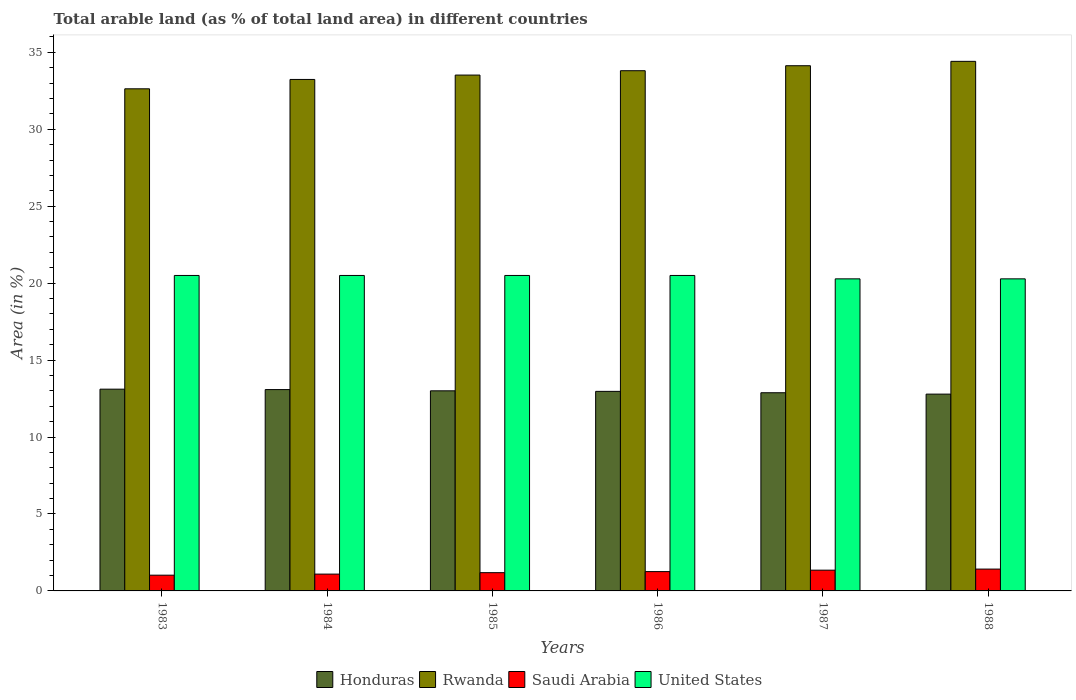How many different coloured bars are there?
Keep it short and to the point. 4. Are the number of bars per tick equal to the number of legend labels?
Offer a very short reply. Yes. How many bars are there on the 5th tick from the left?
Offer a terse response. 4. What is the percentage of arable land in United States in 1985?
Give a very brief answer. 20.5. Across all years, what is the maximum percentage of arable land in Saudi Arabia?
Offer a terse response. 1.42. Across all years, what is the minimum percentage of arable land in Rwanda?
Your answer should be very brief. 32.63. In which year was the percentage of arable land in Honduras maximum?
Your answer should be compact. 1983. In which year was the percentage of arable land in Saudi Arabia minimum?
Your response must be concise. 1983. What is the total percentage of arable land in Honduras in the graph?
Give a very brief answer. 77.84. What is the difference between the percentage of arable land in Rwanda in 1983 and that in 1986?
Provide a succinct answer. -1.18. What is the difference between the percentage of arable land in Saudi Arabia in 1986 and the percentage of arable land in United States in 1985?
Your answer should be compact. -19.24. What is the average percentage of arable land in Rwanda per year?
Make the answer very short. 33.62. In the year 1988, what is the difference between the percentage of arable land in Honduras and percentage of arable land in United States?
Give a very brief answer. -7.49. What is the ratio of the percentage of arable land in United States in 1983 to that in 1988?
Offer a very short reply. 1.01. Is the percentage of arable land in Rwanda in 1983 less than that in 1987?
Your answer should be compact. Yes. Is the difference between the percentage of arable land in Honduras in 1985 and 1988 greater than the difference between the percentage of arable land in United States in 1985 and 1988?
Provide a short and direct response. No. What is the difference between the highest and the second highest percentage of arable land in Honduras?
Offer a very short reply. 0.03. What is the difference between the highest and the lowest percentage of arable land in Saudi Arabia?
Provide a short and direct response. 0.4. In how many years, is the percentage of arable land in Rwanda greater than the average percentage of arable land in Rwanda taken over all years?
Provide a succinct answer. 3. What does the 2nd bar from the left in 1988 represents?
Ensure brevity in your answer.  Rwanda. What does the 1st bar from the right in 1988 represents?
Your response must be concise. United States. How many bars are there?
Ensure brevity in your answer.  24. Are the values on the major ticks of Y-axis written in scientific E-notation?
Provide a short and direct response. No. Where does the legend appear in the graph?
Give a very brief answer. Bottom center. How are the legend labels stacked?
Offer a very short reply. Horizontal. What is the title of the graph?
Your answer should be compact. Total arable land (as % of total land area) in different countries. What is the label or title of the Y-axis?
Keep it short and to the point. Area (in %). What is the Area (in %) of Honduras in 1983?
Your answer should be very brief. 13.11. What is the Area (in %) of Rwanda in 1983?
Your response must be concise. 32.63. What is the Area (in %) of Saudi Arabia in 1983?
Give a very brief answer. 1.02. What is the Area (in %) in United States in 1983?
Keep it short and to the point. 20.5. What is the Area (in %) in Honduras in 1984?
Offer a very short reply. 13.08. What is the Area (in %) in Rwanda in 1984?
Your answer should be compact. 33.24. What is the Area (in %) of Saudi Arabia in 1984?
Offer a terse response. 1.09. What is the Area (in %) in United States in 1984?
Offer a very short reply. 20.5. What is the Area (in %) of Honduras in 1985?
Keep it short and to the point. 13. What is the Area (in %) of Rwanda in 1985?
Your response must be concise. 33.52. What is the Area (in %) in Saudi Arabia in 1985?
Your answer should be compact. 1.19. What is the Area (in %) in United States in 1985?
Provide a succinct answer. 20.5. What is the Area (in %) in Honduras in 1986?
Provide a succinct answer. 12.97. What is the Area (in %) of Rwanda in 1986?
Give a very brief answer. 33.81. What is the Area (in %) of Saudi Arabia in 1986?
Offer a very short reply. 1.26. What is the Area (in %) in United States in 1986?
Make the answer very short. 20.5. What is the Area (in %) of Honduras in 1987?
Provide a short and direct response. 12.88. What is the Area (in %) of Rwanda in 1987?
Your answer should be very brief. 34.13. What is the Area (in %) in Saudi Arabia in 1987?
Your response must be concise. 1.35. What is the Area (in %) in United States in 1987?
Make the answer very short. 20.28. What is the Area (in %) of Honduras in 1988?
Your answer should be compact. 12.79. What is the Area (in %) of Rwanda in 1988?
Make the answer very short. 34.41. What is the Area (in %) of Saudi Arabia in 1988?
Ensure brevity in your answer.  1.42. What is the Area (in %) of United States in 1988?
Your response must be concise. 20.28. Across all years, what is the maximum Area (in %) in Honduras?
Ensure brevity in your answer.  13.11. Across all years, what is the maximum Area (in %) in Rwanda?
Ensure brevity in your answer.  34.41. Across all years, what is the maximum Area (in %) in Saudi Arabia?
Make the answer very short. 1.42. Across all years, what is the maximum Area (in %) in United States?
Your response must be concise. 20.5. Across all years, what is the minimum Area (in %) in Honduras?
Keep it short and to the point. 12.79. Across all years, what is the minimum Area (in %) of Rwanda?
Offer a terse response. 32.63. Across all years, what is the minimum Area (in %) of Saudi Arabia?
Offer a terse response. 1.02. Across all years, what is the minimum Area (in %) in United States?
Keep it short and to the point. 20.28. What is the total Area (in %) in Honduras in the graph?
Offer a very short reply. 77.84. What is the total Area (in %) in Rwanda in the graph?
Keep it short and to the point. 201.74. What is the total Area (in %) of Saudi Arabia in the graph?
Ensure brevity in your answer.  7.33. What is the total Area (in %) in United States in the graph?
Ensure brevity in your answer.  122.56. What is the difference between the Area (in %) in Honduras in 1983 and that in 1984?
Provide a short and direct response. 0.03. What is the difference between the Area (in %) of Rwanda in 1983 and that in 1984?
Make the answer very short. -0.61. What is the difference between the Area (in %) in Saudi Arabia in 1983 and that in 1984?
Provide a succinct answer. -0.07. What is the difference between the Area (in %) in Honduras in 1983 and that in 1985?
Offer a terse response. 0.11. What is the difference between the Area (in %) in Rwanda in 1983 and that in 1985?
Provide a succinct answer. -0.89. What is the difference between the Area (in %) of Saudi Arabia in 1983 and that in 1985?
Provide a short and direct response. -0.16. What is the difference between the Area (in %) in Honduras in 1983 and that in 1986?
Keep it short and to the point. 0.14. What is the difference between the Area (in %) of Rwanda in 1983 and that in 1986?
Keep it short and to the point. -1.18. What is the difference between the Area (in %) of Saudi Arabia in 1983 and that in 1986?
Your answer should be compact. -0.23. What is the difference between the Area (in %) of United States in 1983 and that in 1986?
Offer a terse response. 0. What is the difference between the Area (in %) of Honduras in 1983 and that in 1987?
Provide a short and direct response. 0.23. What is the difference between the Area (in %) of Rwanda in 1983 and that in 1987?
Give a very brief answer. -1.5. What is the difference between the Area (in %) of Saudi Arabia in 1983 and that in 1987?
Give a very brief answer. -0.33. What is the difference between the Area (in %) in United States in 1983 and that in 1987?
Your answer should be compact. 0.22. What is the difference between the Area (in %) of Honduras in 1983 and that in 1988?
Ensure brevity in your answer.  0.32. What is the difference between the Area (in %) of Rwanda in 1983 and that in 1988?
Ensure brevity in your answer.  -1.78. What is the difference between the Area (in %) of Saudi Arabia in 1983 and that in 1988?
Give a very brief answer. -0.4. What is the difference between the Area (in %) of United States in 1983 and that in 1988?
Give a very brief answer. 0.22. What is the difference between the Area (in %) in Honduras in 1984 and that in 1985?
Give a very brief answer. 0.08. What is the difference between the Area (in %) in Rwanda in 1984 and that in 1985?
Your answer should be very brief. -0.28. What is the difference between the Area (in %) of Saudi Arabia in 1984 and that in 1985?
Your response must be concise. -0.09. What is the difference between the Area (in %) in Honduras in 1984 and that in 1986?
Give a very brief answer. 0.12. What is the difference between the Area (in %) of Rwanda in 1984 and that in 1986?
Your response must be concise. -0.57. What is the difference between the Area (in %) of Saudi Arabia in 1984 and that in 1986?
Ensure brevity in your answer.  -0.16. What is the difference between the Area (in %) of Honduras in 1984 and that in 1987?
Offer a very short reply. 0.21. What is the difference between the Area (in %) of Rwanda in 1984 and that in 1987?
Keep it short and to the point. -0.89. What is the difference between the Area (in %) of Saudi Arabia in 1984 and that in 1987?
Give a very brief answer. -0.26. What is the difference between the Area (in %) in United States in 1984 and that in 1987?
Offer a terse response. 0.22. What is the difference between the Area (in %) in Honduras in 1984 and that in 1988?
Your response must be concise. 0.29. What is the difference between the Area (in %) in Rwanda in 1984 and that in 1988?
Provide a succinct answer. -1.18. What is the difference between the Area (in %) in Saudi Arabia in 1984 and that in 1988?
Make the answer very short. -0.33. What is the difference between the Area (in %) in United States in 1984 and that in 1988?
Give a very brief answer. 0.22. What is the difference between the Area (in %) in Honduras in 1985 and that in 1986?
Make the answer very short. 0.04. What is the difference between the Area (in %) of Rwanda in 1985 and that in 1986?
Provide a short and direct response. -0.28. What is the difference between the Area (in %) in Saudi Arabia in 1985 and that in 1986?
Keep it short and to the point. -0.07. What is the difference between the Area (in %) of Honduras in 1985 and that in 1987?
Keep it short and to the point. 0.13. What is the difference between the Area (in %) in Rwanda in 1985 and that in 1987?
Your answer should be very brief. -0.61. What is the difference between the Area (in %) of Saudi Arabia in 1985 and that in 1987?
Give a very brief answer. -0.16. What is the difference between the Area (in %) of United States in 1985 and that in 1987?
Give a very brief answer. 0.22. What is the difference between the Area (in %) in Honduras in 1985 and that in 1988?
Keep it short and to the point. 0.21. What is the difference between the Area (in %) of Rwanda in 1985 and that in 1988?
Offer a terse response. -0.89. What is the difference between the Area (in %) in Saudi Arabia in 1985 and that in 1988?
Your answer should be compact. -0.23. What is the difference between the Area (in %) in United States in 1985 and that in 1988?
Your answer should be very brief. 0.22. What is the difference between the Area (in %) of Honduras in 1986 and that in 1987?
Your answer should be very brief. 0.09. What is the difference between the Area (in %) in Rwanda in 1986 and that in 1987?
Keep it short and to the point. -0.32. What is the difference between the Area (in %) of Saudi Arabia in 1986 and that in 1987?
Offer a terse response. -0.09. What is the difference between the Area (in %) in United States in 1986 and that in 1987?
Keep it short and to the point. 0.22. What is the difference between the Area (in %) in Honduras in 1986 and that in 1988?
Keep it short and to the point. 0.18. What is the difference between the Area (in %) in Rwanda in 1986 and that in 1988?
Your answer should be very brief. -0.61. What is the difference between the Area (in %) in Saudi Arabia in 1986 and that in 1988?
Keep it short and to the point. -0.16. What is the difference between the Area (in %) in United States in 1986 and that in 1988?
Ensure brevity in your answer.  0.22. What is the difference between the Area (in %) of Honduras in 1987 and that in 1988?
Your answer should be very brief. 0.09. What is the difference between the Area (in %) in Rwanda in 1987 and that in 1988?
Offer a very short reply. -0.28. What is the difference between the Area (in %) in Saudi Arabia in 1987 and that in 1988?
Your answer should be very brief. -0.07. What is the difference between the Area (in %) in United States in 1987 and that in 1988?
Offer a very short reply. 0. What is the difference between the Area (in %) in Honduras in 1983 and the Area (in %) in Rwanda in 1984?
Your answer should be very brief. -20.13. What is the difference between the Area (in %) in Honduras in 1983 and the Area (in %) in Saudi Arabia in 1984?
Provide a succinct answer. 12.02. What is the difference between the Area (in %) of Honduras in 1983 and the Area (in %) of United States in 1984?
Ensure brevity in your answer.  -7.39. What is the difference between the Area (in %) of Rwanda in 1983 and the Area (in %) of Saudi Arabia in 1984?
Ensure brevity in your answer.  31.54. What is the difference between the Area (in %) of Rwanda in 1983 and the Area (in %) of United States in 1984?
Give a very brief answer. 12.13. What is the difference between the Area (in %) of Saudi Arabia in 1983 and the Area (in %) of United States in 1984?
Offer a terse response. -19.48. What is the difference between the Area (in %) in Honduras in 1983 and the Area (in %) in Rwanda in 1985?
Your answer should be compact. -20.41. What is the difference between the Area (in %) in Honduras in 1983 and the Area (in %) in Saudi Arabia in 1985?
Your response must be concise. 11.92. What is the difference between the Area (in %) of Honduras in 1983 and the Area (in %) of United States in 1985?
Provide a short and direct response. -7.39. What is the difference between the Area (in %) in Rwanda in 1983 and the Area (in %) in Saudi Arabia in 1985?
Make the answer very short. 31.44. What is the difference between the Area (in %) of Rwanda in 1983 and the Area (in %) of United States in 1985?
Offer a very short reply. 12.13. What is the difference between the Area (in %) in Saudi Arabia in 1983 and the Area (in %) in United States in 1985?
Your response must be concise. -19.48. What is the difference between the Area (in %) of Honduras in 1983 and the Area (in %) of Rwanda in 1986?
Offer a very short reply. -20.7. What is the difference between the Area (in %) of Honduras in 1983 and the Area (in %) of Saudi Arabia in 1986?
Provide a succinct answer. 11.86. What is the difference between the Area (in %) of Honduras in 1983 and the Area (in %) of United States in 1986?
Your answer should be very brief. -7.39. What is the difference between the Area (in %) in Rwanda in 1983 and the Area (in %) in Saudi Arabia in 1986?
Provide a short and direct response. 31.37. What is the difference between the Area (in %) of Rwanda in 1983 and the Area (in %) of United States in 1986?
Make the answer very short. 12.13. What is the difference between the Area (in %) of Saudi Arabia in 1983 and the Area (in %) of United States in 1986?
Your answer should be compact. -19.48. What is the difference between the Area (in %) of Honduras in 1983 and the Area (in %) of Rwanda in 1987?
Provide a short and direct response. -21.02. What is the difference between the Area (in %) of Honduras in 1983 and the Area (in %) of Saudi Arabia in 1987?
Give a very brief answer. 11.76. What is the difference between the Area (in %) of Honduras in 1983 and the Area (in %) of United States in 1987?
Offer a very short reply. -7.17. What is the difference between the Area (in %) of Rwanda in 1983 and the Area (in %) of Saudi Arabia in 1987?
Provide a succinct answer. 31.28. What is the difference between the Area (in %) in Rwanda in 1983 and the Area (in %) in United States in 1987?
Your answer should be compact. 12.35. What is the difference between the Area (in %) in Saudi Arabia in 1983 and the Area (in %) in United States in 1987?
Offer a terse response. -19.26. What is the difference between the Area (in %) of Honduras in 1983 and the Area (in %) of Rwanda in 1988?
Your answer should be very brief. -21.3. What is the difference between the Area (in %) of Honduras in 1983 and the Area (in %) of Saudi Arabia in 1988?
Your answer should be compact. 11.69. What is the difference between the Area (in %) of Honduras in 1983 and the Area (in %) of United States in 1988?
Your response must be concise. -7.17. What is the difference between the Area (in %) of Rwanda in 1983 and the Area (in %) of Saudi Arabia in 1988?
Your answer should be very brief. 31.21. What is the difference between the Area (in %) in Rwanda in 1983 and the Area (in %) in United States in 1988?
Your response must be concise. 12.35. What is the difference between the Area (in %) in Saudi Arabia in 1983 and the Area (in %) in United States in 1988?
Give a very brief answer. -19.26. What is the difference between the Area (in %) of Honduras in 1984 and the Area (in %) of Rwanda in 1985?
Offer a terse response. -20.44. What is the difference between the Area (in %) of Honduras in 1984 and the Area (in %) of Saudi Arabia in 1985?
Offer a terse response. 11.9. What is the difference between the Area (in %) in Honduras in 1984 and the Area (in %) in United States in 1985?
Your response must be concise. -7.42. What is the difference between the Area (in %) of Rwanda in 1984 and the Area (in %) of Saudi Arabia in 1985?
Make the answer very short. 32.05. What is the difference between the Area (in %) of Rwanda in 1984 and the Area (in %) of United States in 1985?
Offer a very short reply. 12.74. What is the difference between the Area (in %) in Saudi Arabia in 1984 and the Area (in %) in United States in 1985?
Ensure brevity in your answer.  -19.41. What is the difference between the Area (in %) of Honduras in 1984 and the Area (in %) of Rwanda in 1986?
Your answer should be compact. -20.72. What is the difference between the Area (in %) in Honduras in 1984 and the Area (in %) in Saudi Arabia in 1986?
Provide a short and direct response. 11.83. What is the difference between the Area (in %) in Honduras in 1984 and the Area (in %) in United States in 1986?
Make the answer very short. -7.42. What is the difference between the Area (in %) in Rwanda in 1984 and the Area (in %) in Saudi Arabia in 1986?
Give a very brief answer. 31.98. What is the difference between the Area (in %) of Rwanda in 1984 and the Area (in %) of United States in 1986?
Give a very brief answer. 12.74. What is the difference between the Area (in %) of Saudi Arabia in 1984 and the Area (in %) of United States in 1986?
Give a very brief answer. -19.41. What is the difference between the Area (in %) of Honduras in 1984 and the Area (in %) of Rwanda in 1987?
Provide a succinct answer. -21.05. What is the difference between the Area (in %) in Honduras in 1984 and the Area (in %) in Saudi Arabia in 1987?
Your answer should be compact. 11.74. What is the difference between the Area (in %) in Honduras in 1984 and the Area (in %) in United States in 1987?
Give a very brief answer. -7.2. What is the difference between the Area (in %) of Rwanda in 1984 and the Area (in %) of Saudi Arabia in 1987?
Provide a succinct answer. 31.89. What is the difference between the Area (in %) of Rwanda in 1984 and the Area (in %) of United States in 1987?
Provide a succinct answer. 12.96. What is the difference between the Area (in %) of Saudi Arabia in 1984 and the Area (in %) of United States in 1987?
Offer a terse response. -19.19. What is the difference between the Area (in %) in Honduras in 1984 and the Area (in %) in Rwanda in 1988?
Keep it short and to the point. -21.33. What is the difference between the Area (in %) of Honduras in 1984 and the Area (in %) of Saudi Arabia in 1988?
Your response must be concise. 11.67. What is the difference between the Area (in %) in Honduras in 1984 and the Area (in %) in United States in 1988?
Give a very brief answer. -7.2. What is the difference between the Area (in %) of Rwanda in 1984 and the Area (in %) of Saudi Arabia in 1988?
Offer a terse response. 31.82. What is the difference between the Area (in %) in Rwanda in 1984 and the Area (in %) in United States in 1988?
Ensure brevity in your answer.  12.96. What is the difference between the Area (in %) in Saudi Arabia in 1984 and the Area (in %) in United States in 1988?
Offer a terse response. -19.19. What is the difference between the Area (in %) in Honduras in 1985 and the Area (in %) in Rwanda in 1986?
Offer a very short reply. -20.8. What is the difference between the Area (in %) of Honduras in 1985 and the Area (in %) of Saudi Arabia in 1986?
Provide a short and direct response. 11.75. What is the difference between the Area (in %) in Honduras in 1985 and the Area (in %) in United States in 1986?
Your answer should be compact. -7.5. What is the difference between the Area (in %) of Rwanda in 1985 and the Area (in %) of Saudi Arabia in 1986?
Keep it short and to the point. 32.27. What is the difference between the Area (in %) in Rwanda in 1985 and the Area (in %) in United States in 1986?
Offer a very short reply. 13.02. What is the difference between the Area (in %) of Saudi Arabia in 1985 and the Area (in %) of United States in 1986?
Your answer should be compact. -19.31. What is the difference between the Area (in %) in Honduras in 1985 and the Area (in %) in Rwanda in 1987?
Your response must be concise. -21.13. What is the difference between the Area (in %) of Honduras in 1985 and the Area (in %) of Saudi Arabia in 1987?
Your answer should be compact. 11.65. What is the difference between the Area (in %) in Honduras in 1985 and the Area (in %) in United States in 1987?
Offer a very short reply. -7.28. What is the difference between the Area (in %) in Rwanda in 1985 and the Area (in %) in Saudi Arabia in 1987?
Give a very brief answer. 32.17. What is the difference between the Area (in %) of Rwanda in 1985 and the Area (in %) of United States in 1987?
Your answer should be compact. 13.24. What is the difference between the Area (in %) in Saudi Arabia in 1985 and the Area (in %) in United States in 1987?
Your answer should be compact. -19.09. What is the difference between the Area (in %) in Honduras in 1985 and the Area (in %) in Rwanda in 1988?
Offer a terse response. -21.41. What is the difference between the Area (in %) in Honduras in 1985 and the Area (in %) in Saudi Arabia in 1988?
Ensure brevity in your answer.  11.59. What is the difference between the Area (in %) of Honduras in 1985 and the Area (in %) of United States in 1988?
Your answer should be compact. -7.28. What is the difference between the Area (in %) in Rwanda in 1985 and the Area (in %) in Saudi Arabia in 1988?
Make the answer very short. 32.1. What is the difference between the Area (in %) in Rwanda in 1985 and the Area (in %) in United States in 1988?
Offer a terse response. 13.24. What is the difference between the Area (in %) in Saudi Arabia in 1985 and the Area (in %) in United States in 1988?
Give a very brief answer. -19.09. What is the difference between the Area (in %) of Honduras in 1986 and the Area (in %) of Rwanda in 1987?
Your answer should be compact. -21.16. What is the difference between the Area (in %) of Honduras in 1986 and the Area (in %) of Saudi Arabia in 1987?
Provide a short and direct response. 11.62. What is the difference between the Area (in %) in Honduras in 1986 and the Area (in %) in United States in 1987?
Keep it short and to the point. -7.31. What is the difference between the Area (in %) in Rwanda in 1986 and the Area (in %) in Saudi Arabia in 1987?
Offer a very short reply. 32.46. What is the difference between the Area (in %) in Rwanda in 1986 and the Area (in %) in United States in 1987?
Ensure brevity in your answer.  13.53. What is the difference between the Area (in %) of Saudi Arabia in 1986 and the Area (in %) of United States in 1987?
Offer a very short reply. -19.02. What is the difference between the Area (in %) of Honduras in 1986 and the Area (in %) of Rwanda in 1988?
Offer a terse response. -21.45. What is the difference between the Area (in %) in Honduras in 1986 and the Area (in %) in Saudi Arabia in 1988?
Provide a short and direct response. 11.55. What is the difference between the Area (in %) of Honduras in 1986 and the Area (in %) of United States in 1988?
Keep it short and to the point. -7.31. What is the difference between the Area (in %) in Rwanda in 1986 and the Area (in %) in Saudi Arabia in 1988?
Provide a short and direct response. 32.39. What is the difference between the Area (in %) in Rwanda in 1986 and the Area (in %) in United States in 1988?
Offer a terse response. 13.53. What is the difference between the Area (in %) in Saudi Arabia in 1986 and the Area (in %) in United States in 1988?
Keep it short and to the point. -19.02. What is the difference between the Area (in %) in Honduras in 1987 and the Area (in %) in Rwanda in 1988?
Provide a succinct answer. -21.54. What is the difference between the Area (in %) in Honduras in 1987 and the Area (in %) in Saudi Arabia in 1988?
Offer a terse response. 11.46. What is the difference between the Area (in %) of Honduras in 1987 and the Area (in %) of United States in 1988?
Give a very brief answer. -7.4. What is the difference between the Area (in %) of Rwanda in 1987 and the Area (in %) of Saudi Arabia in 1988?
Make the answer very short. 32.71. What is the difference between the Area (in %) of Rwanda in 1987 and the Area (in %) of United States in 1988?
Give a very brief answer. 13.85. What is the difference between the Area (in %) in Saudi Arabia in 1987 and the Area (in %) in United States in 1988?
Offer a very short reply. -18.93. What is the average Area (in %) in Honduras per year?
Your answer should be compact. 12.97. What is the average Area (in %) of Rwanda per year?
Your response must be concise. 33.62. What is the average Area (in %) in Saudi Arabia per year?
Your answer should be compact. 1.22. What is the average Area (in %) in United States per year?
Your answer should be very brief. 20.43. In the year 1983, what is the difference between the Area (in %) of Honduras and Area (in %) of Rwanda?
Provide a short and direct response. -19.52. In the year 1983, what is the difference between the Area (in %) of Honduras and Area (in %) of Saudi Arabia?
Provide a short and direct response. 12.09. In the year 1983, what is the difference between the Area (in %) in Honduras and Area (in %) in United States?
Provide a short and direct response. -7.39. In the year 1983, what is the difference between the Area (in %) in Rwanda and Area (in %) in Saudi Arabia?
Ensure brevity in your answer.  31.61. In the year 1983, what is the difference between the Area (in %) of Rwanda and Area (in %) of United States?
Your answer should be compact. 12.13. In the year 1983, what is the difference between the Area (in %) of Saudi Arabia and Area (in %) of United States?
Keep it short and to the point. -19.48. In the year 1984, what is the difference between the Area (in %) of Honduras and Area (in %) of Rwanda?
Provide a short and direct response. -20.15. In the year 1984, what is the difference between the Area (in %) in Honduras and Area (in %) in Saudi Arabia?
Your answer should be very brief. 11.99. In the year 1984, what is the difference between the Area (in %) of Honduras and Area (in %) of United States?
Your response must be concise. -7.42. In the year 1984, what is the difference between the Area (in %) of Rwanda and Area (in %) of Saudi Arabia?
Your answer should be compact. 32.15. In the year 1984, what is the difference between the Area (in %) in Rwanda and Area (in %) in United States?
Your answer should be very brief. 12.74. In the year 1984, what is the difference between the Area (in %) in Saudi Arabia and Area (in %) in United States?
Your response must be concise. -19.41. In the year 1985, what is the difference between the Area (in %) of Honduras and Area (in %) of Rwanda?
Offer a terse response. -20.52. In the year 1985, what is the difference between the Area (in %) in Honduras and Area (in %) in Saudi Arabia?
Your response must be concise. 11.82. In the year 1985, what is the difference between the Area (in %) of Honduras and Area (in %) of United States?
Provide a short and direct response. -7.5. In the year 1985, what is the difference between the Area (in %) of Rwanda and Area (in %) of Saudi Arabia?
Provide a short and direct response. 32.34. In the year 1985, what is the difference between the Area (in %) in Rwanda and Area (in %) in United States?
Keep it short and to the point. 13.02. In the year 1985, what is the difference between the Area (in %) in Saudi Arabia and Area (in %) in United States?
Keep it short and to the point. -19.31. In the year 1986, what is the difference between the Area (in %) of Honduras and Area (in %) of Rwanda?
Give a very brief answer. -20.84. In the year 1986, what is the difference between the Area (in %) of Honduras and Area (in %) of Saudi Arabia?
Your answer should be compact. 11.71. In the year 1986, what is the difference between the Area (in %) of Honduras and Area (in %) of United States?
Offer a terse response. -7.53. In the year 1986, what is the difference between the Area (in %) in Rwanda and Area (in %) in Saudi Arabia?
Offer a very short reply. 32.55. In the year 1986, what is the difference between the Area (in %) in Rwanda and Area (in %) in United States?
Your answer should be very brief. 13.31. In the year 1986, what is the difference between the Area (in %) in Saudi Arabia and Area (in %) in United States?
Provide a succinct answer. -19.24. In the year 1987, what is the difference between the Area (in %) of Honduras and Area (in %) of Rwanda?
Offer a terse response. -21.25. In the year 1987, what is the difference between the Area (in %) in Honduras and Area (in %) in Saudi Arabia?
Your answer should be compact. 11.53. In the year 1987, what is the difference between the Area (in %) in Honduras and Area (in %) in United States?
Keep it short and to the point. -7.4. In the year 1987, what is the difference between the Area (in %) in Rwanda and Area (in %) in Saudi Arabia?
Make the answer very short. 32.78. In the year 1987, what is the difference between the Area (in %) of Rwanda and Area (in %) of United States?
Your answer should be compact. 13.85. In the year 1987, what is the difference between the Area (in %) in Saudi Arabia and Area (in %) in United States?
Give a very brief answer. -18.93. In the year 1988, what is the difference between the Area (in %) of Honduras and Area (in %) of Rwanda?
Give a very brief answer. -21.62. In the year 1988, what is the difference between the Area (in %) in Honduras and Area (in %) in Saudi Arabia?
Make the answer very short. 11.37. In the year 1988, what is the difference between the Area (in %) of Honduras and Area (in %) of United States?
Your answer should be compact. -7.49. In the year 1988, what is the difference between the Area (in %) of Rwanda and Area (in %) of Saudi Arabia?
Provide a short and direct response. 33. In the year 1988, what is the difference between the Area (in %) of Rwanda and Area (in %) of United States?
Your answer should be very brief. 14.13. In the year 1988, what is the difference between the Area (in %) of Saudi Arabia and Area (in %) of United States?
Make the answer very short. -18.86. What is the ratio of the Area (in %) of Rwanda in 1983 to that in 1984?
Keep it short and to the point. 0.98. What is the ratio of the Area (in %) in Saudi Arabia in 1983 to that in 1984?
Offer a very short reply. 0.94. What is the ratio of the Area (in %) of United States in 1983 to that in 1984?
Offer a terse response. 1. What is the ratio of the Area (in %) of Honduras in 1983 to that in 1985?
Provide a succinct answer. 1.01. What is the ratio of the Area (in %) of Rwanda in 1983 to that in 1985?
Provide a short and direct response. 0.97. What is the ratio of the Area (in %) of Saudi Arabia in 1983 to that in 1985?
Provide a short and direct response. 0.86. What is the ratio of the Area (in %) in Honduras in 1983 to that in 1986?
Offer a terse response. 1.01. What is the ratio of the Area (in %) in Rwanda in 1983 to that in 1986?
Offer a terse response. 0.97. What is the ratio of the Area (in %) of Saudi Arabia in 1983 to that in 1986?
Offer a very short reply. 0.81. What is the ratio of the Area (in %) of Honduras in 1983 to that in 1987?
Keep it short and to the point. 1.02. What is the ratio of the Area (in %) in Rwanda in 1983 to that in 1987?
Offer a terse response. 0.96. What is the ratio of the Area (in %) of Saudi Arabia in 1983 to that in 1987?
Your answer should be very brief. 0.76. What is the ratio of the Area (in %) of United States in 1983 to that in 1987?
Provide a succinct answer. 1.01. What is the ratio of the Area (in %) of Honduras in 1983 to that in 1988?
Provide a short and direct response. 1.03. What is the ratio of the Area (in %) of Rwanda in 1983 to that in 1988?
Your response must be concise. 0.95. What is the ratio of the Area (in %) in Saudi Arabia in 1983 to that in 1988?
Make the answer very short. 0.72. What is the ratio of the Area (in %) of United States in 1983 to that in 1988?
Keep it short and to the point. 1.01. What is the ratio of the Area (in %) of Honduras in 1984 to that in 1985?
Your answer should be very brief. 1.01. What is the ratio of the Area (in %) of Rwanda in 1984 to that in 1985?
Your answer should be very brief. 0.99. What is the ratio of the Area (in %) of Saudi Arabia in 1984 to that in 1985?
Your answer should be compact. 0.92. What is the ratio of the Area (in %) of United States in 1984 to that in 1985?
Keep it short and to the point. 1. What is the ratio of the Area (in %) in Honduras in 1984 to that in 1986?
Offer a very short reply. 1.01. What is the ratio of the Area (in %) in Rwanda in 1984 to that in 1986?
Your answer should be very brief. 0.98. What is the ratio of the Area (in %) in Saudi Arabia in 1984 to that in 1986?
Make the answer very short. 0.87. What is the ratio of the Area (in %) in Honduras in 1984 to that in 1987?
Offer a terse response. 1.02. What is the ratio of the Area (in %) in Rwanda in 1984 to that in 1987?
Your answer should be compact. 0.97. What is the ratio of the Area (in %) in Saudi Arabia in 1984 to that in 1987?
Offer a terse response. 0.81. What is the ratio of the Area (in %) in United States in 1984 to that in 1987?
Ensure brevity in your answer.  1.01. What is the ratio of the Area (in %) in Honduras in 1984 to that in 1988?
Keep it short and to the point. 1.02. What is the ratio of the Area (in %) of Rwanda in 1984 to that in 1988?
Provide a short and direct response. 0.97. What is the ratio of the Area (in %) in Saudi Arabia in 1984 to that in 1988?
Offer a very short reply. 0.77. What is the ratio of the Area (in %) in United States in 1984 to that in 1988?
Keep it short and to the point. 1.01. What is the ratio of the Area (in %) of United States in 1985 to that in 1986?
Ensure brevity in your answer.  1. What is the ratio of the Area (in %) of Honduras in 1985 to that in 1987?
Ensure brevity in your answer.  1.01. What is the ratio of the Area (in %) in Rwanda in 1985 to that in 1987?
Your response must be concise. 0.98. What is the ratio of the Area (in %) of Saudi Arabia in 1985 to that in 1987?
Your response must be concise. 0.88. What is the ratio of the Area (in %) of United States in 1985 to that in 1987?
Your answer should be compact. 1.01. What is the ratio of the Area (in %) of Honduras in 1985 to that in 1988?
Offer a terse response. 1.02. What is the ratio of the Area (in %) in Rwanda in 1985 to that in 1988?
Make the answer very short. 0.97. What is the ratio of the Area (in %) in Saudi Arabia in 1985 to that in 1988?
Provide a succinct answer. 0.84. What is the ratio of the Area (in %) of United States in 1985 to that in 1988?
Your answer should be compact. 1.01. What is the ratio of the Area (in %) in Honduras in 1986 to that in 1987?
Your answer should be compact. 1.01. What is the ratio of the Area (in %) in Rwanda in 1986 to that in 1987?
Keep it short and to the point. 0.99. What is the ratio of the Area (in %) in United States in 1986 to that in 1987?
Your answer should be very brief. 1.01. What is the ratio of the Area (in %) of Rwanda in 1986 to that in 1988?
Your answer should be compact. 0.98. What is the ratio of the Area (in %) of Saudi Arabia in 1986 to that in 1988?
Ensure brevity in your answer.  0.89. What is the ratio of the Area (in %) of United States in 1986 to that in 1988?
Provide a succinct answer. 1.01. What is the ratio of the Area (in %) in Saudi Arabia in 1987 to that in 1988?
Ensure brevity in your answer.  0.95. What is the ratio of the Area (in %) in United States in 1987 to that in 1988?
Your response must be concise. 1. What is the difference between the highest and the second highest Area (in %) in Honduras?
Offer a terse response. 0.03. What is the difference between the highest and the second highest Area (in %) of Rwanda?
Ensure brevity in your answer.  0.28. What is the difference between the highest and the second highest Area (in %) of Saudi Arabia?
Provide a short and direct response. 0.07. What is the difference between the highest and the lowest Area (in %) of Honduras?
Your answer should be compact. 0.32. What is the difference between the highest and the lowest Area (in %) of Rwanda?
Give a very brief answer. 1.78. What is the difference between the highest and the lowest Area (in %) in Saudi Arabia?
Make the answer very short. 0.4. What is the difference between the highest and the lowest Area (in %) of United States?
Offer a terse response. 0.22. 